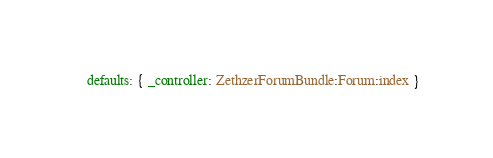Convert code to text. <code><loc_0><loc_0><loc_500><loc_500><_YAML_>    defaults: { _controller: ZethzerForumBundle:Forum:index }
</code> 